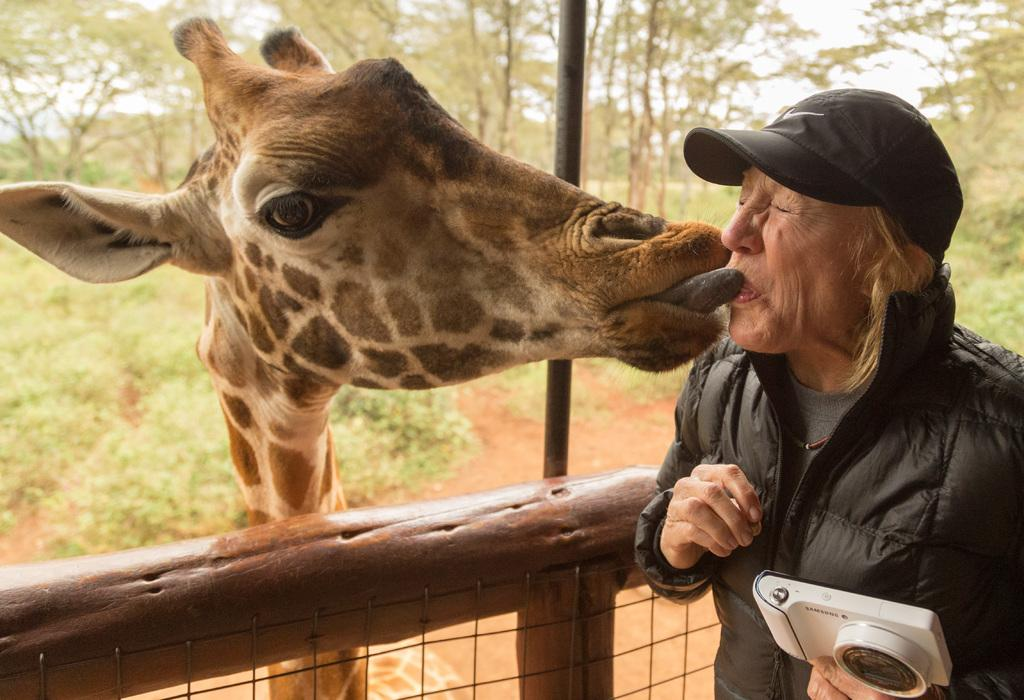Who or what is on the right side of the image? There is a person on the right side of the image. What animal is on the left side of the image? There is a giraffe on the left side of the image. What type of vegetation can be seen in the background of the image? There are trees visible in the background of the image. What type of ship can be seen sailing in the sea in the image? There is no ship or sea present in the image; it features a person and a giraffe with trees in the background. 